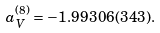<formula> <loc_0><loc_0><loc_500><loc_500>a _ { V } ^ { ( 8 ) } = - 1 . 9 9 3 0 6 ( 3 4 3 ) .</formula> 